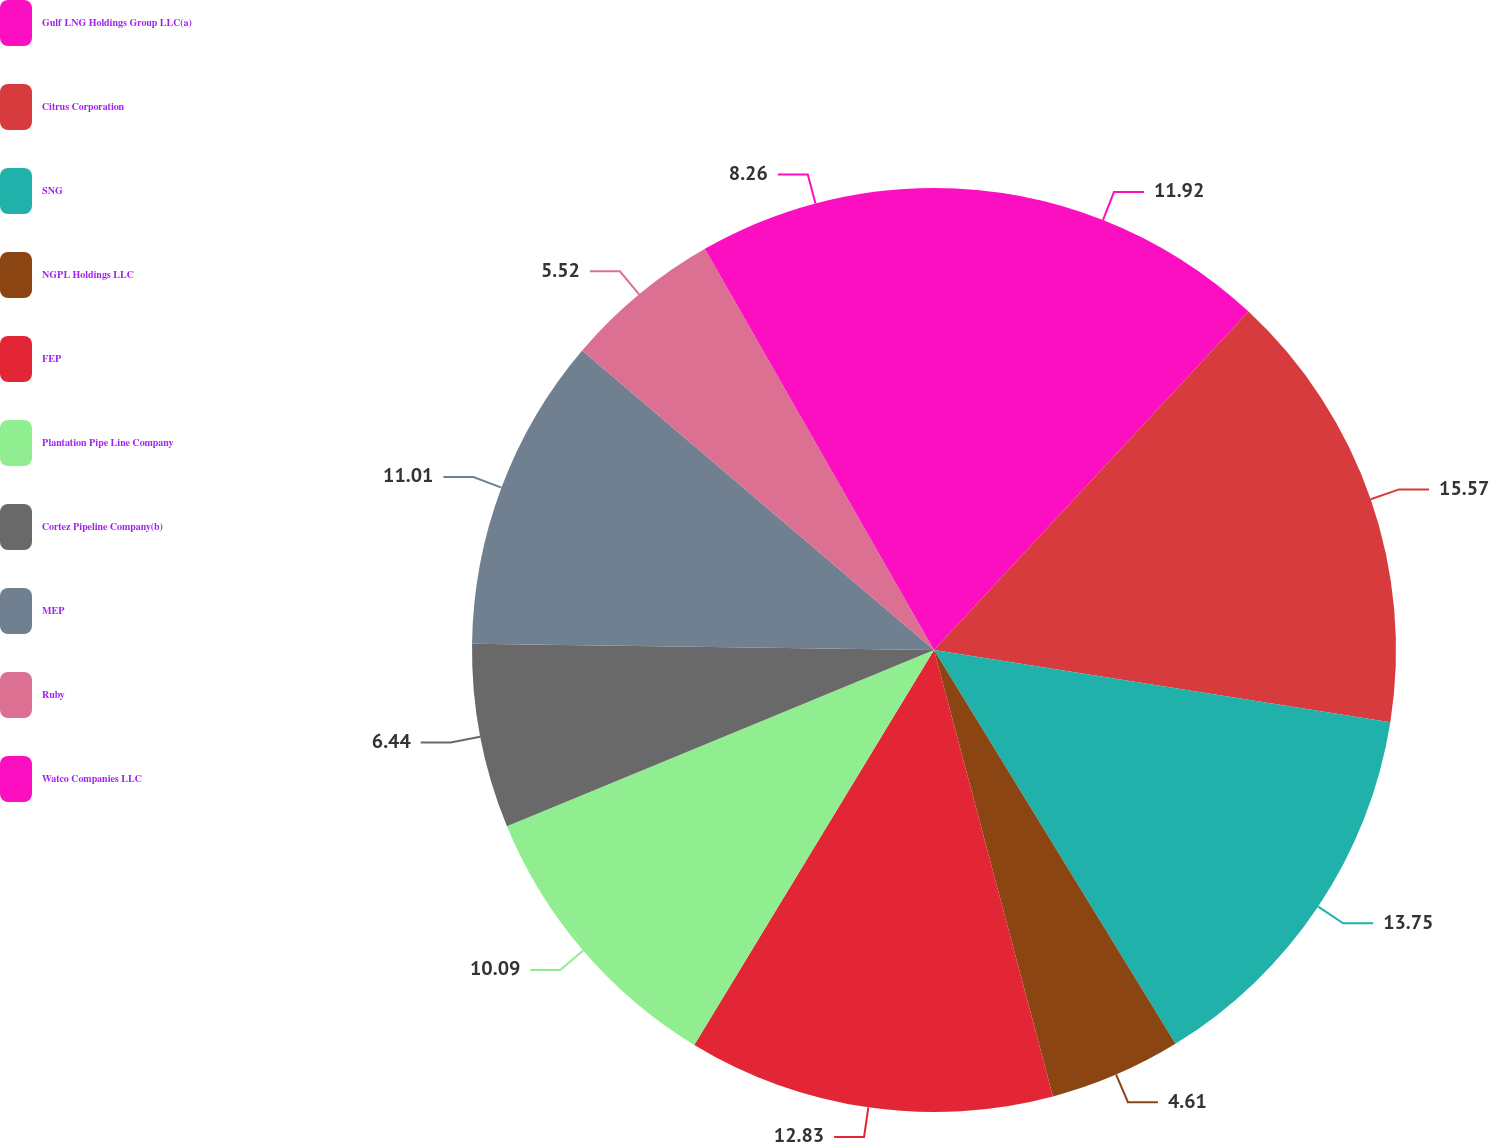Convert chart to OTSL. <chart><loc_0><loc_0><loc_500><loc_500><pie_chart><fcel>Gulf LNG Holdings Group LLC(a)<fcel>Citrus Corporation<fcel>SNG<fcel>NGPL Holdings LLC<fcel>FEP<fcel>Plantation Pipe Line Company<fcel>Cortez Pipeline Company(b)<fcel>MEP<fcel>Ruby<fcel>Watco Companies LLC<nl><fcel>11.92%<fcel>15.58%<fcel>13.75%<fcel>4.61%<fcel>12.83%<fcel>10.09%<fcel>6.44%<fcel>11.01%<fcel>5.52%<fcel>8.26%<nl></chart> 